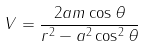<formula> <loc_0><loc_0><loc_500><loc_500>V = \frac { 2 a m \cos \theta } { r ^ { 2 } - a ^ { 2 } \cos ^ { 2 } \theta }</formula> 